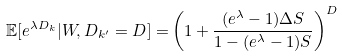<formula> <loc_0><loc_0><loc_500><loc_500>\mathbb { E } [ e ^ { \lambda D _ { k } } | W , D _ { k ^ { \prime } } = D ] = & \left ( 1 + \frac { ( e ^ { \lambda } - 1 ) \Delta S } { 1 - ( e ^ { \lambda } - 1 ) S } \right ) ^ { D }</formula> 